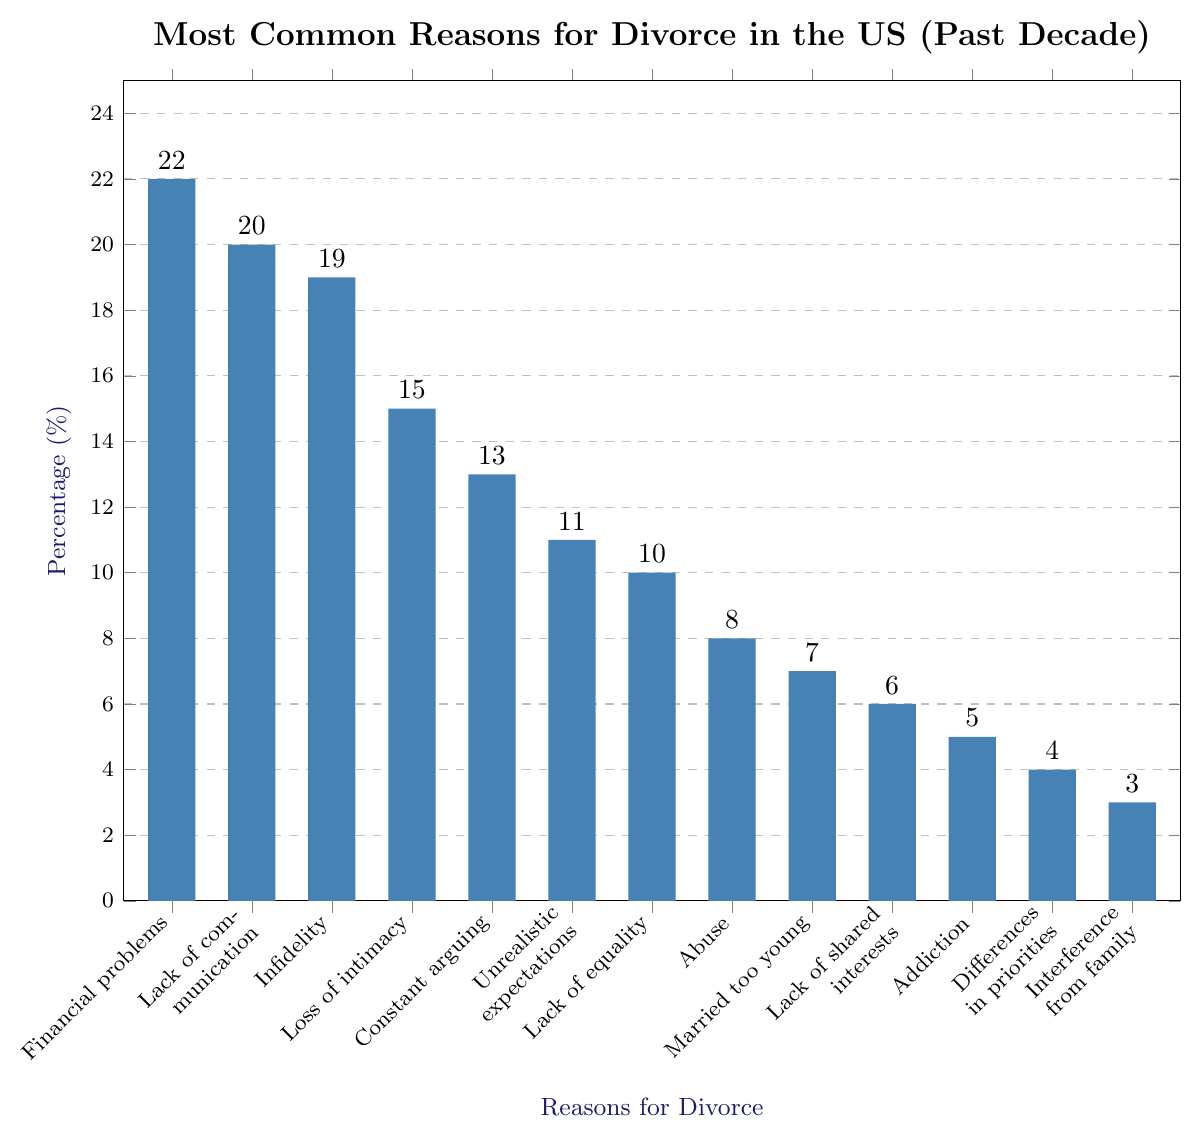Which reason for divorce has the highest percentage? The bar for "Financial problems" is the tallest one, indicating it has the highest percentage.
Answer: Financial problems What are the top three most common reasons for divorce? The three tallest bars are "Financial problems," "Lack of communication," and "Infidelity."
Answer: Financial problems, Lack of communication, Infidelity How much higher is the percentage for "Infidelity" compared to "Lack of equality"? The percentage for "Infidelity" is 19%, and for "Lack of equality," it is 10%. The difference is 19% - 10% = 9%.
Answer: 9% What is the total percentage for the least common three reasons for divorce? The percentages for the three least common reasons are "Interference from family" (3%), "Differences in priorities" (4%), and "Addiction" (5%). The total is 3% + 4% + 5% = 12%.
Answer: 12% Which reason for divorce has a slightly higher percentage than "Lack of equality"? The bar for "Unrealistic expectations" is just above "Lack of equality." The percentage for "Unrealistic expectations" is 11%, while "Lack of equality" is 10%.
Answer: Unrealistic expectations How much lower is the percentage for "Abuse" compared to "Loss of intimacy"? The percentage for "Abuse" is 8%, and for "Loss of intimacy," it is 15%. The difference is 15% - 8% = 7%.
Answer: 7% Which reasons for divorce have a percentage greater than 15%? The bars for "Financial problems" (22%), "Lack of communication" (20%), and "Infidelity" (19%) all have percentages greater than 15%.
Answer: Financial problems, Lack of communication, Infidelity How many reasons have a percentage less than 10%? The bars for "Abuse" (8%), "Married too young" (7%), "Lack of shared interests" (6%), "Addiction" (5%), "Differences in priorities" (4%), and "Interference from family" (3%) all have percentages less than 10%. This sums to 6 reasons.
Answer: 6 What is the percentage difference between "Constant arguing" and "Lack of communication"? The percentage for "Constant arguing" is 13%, and for "Lack of communication," it is 20%. The difference is 20% - 13% = 7%.
Answer: 7% 